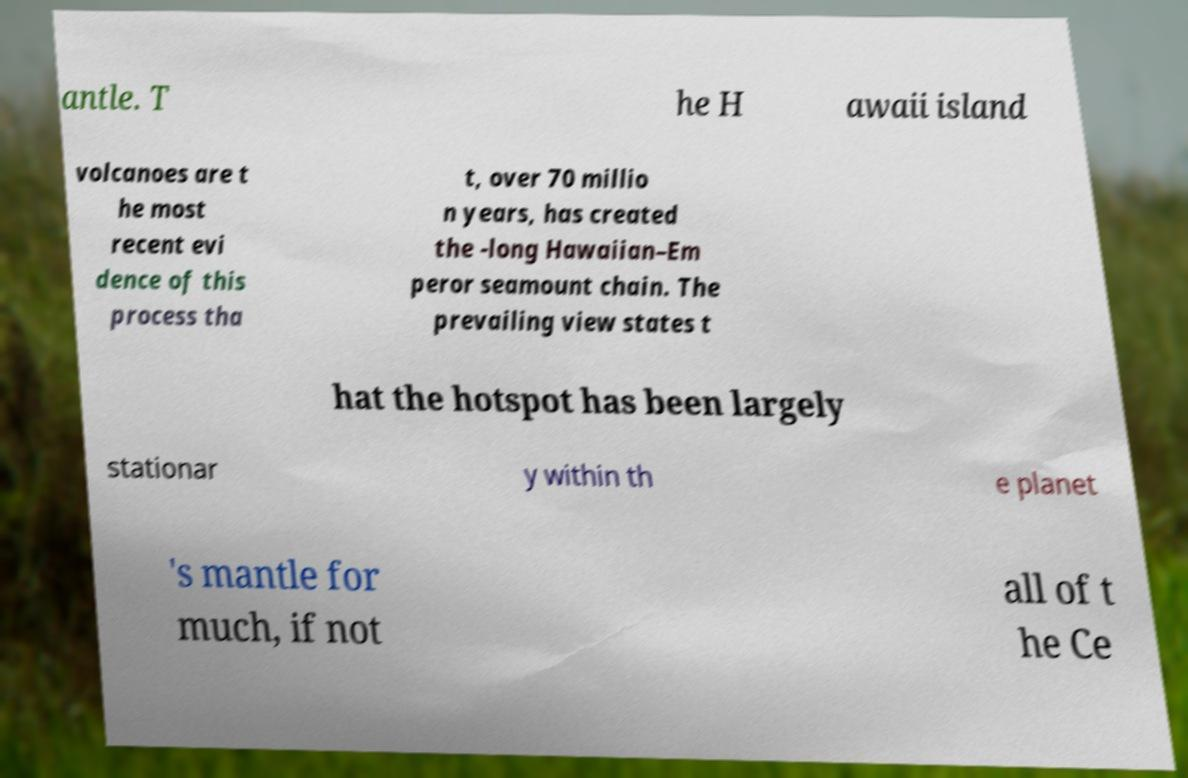Can you accurately transcribe the text from the provided image for me? antle. T he H awaii island volcanoes are t he most recent evi dence of this process tha t, over 70 millio n years, has created the -long Hawaiian–Em peror seamount chain. The prevailing view states t hat the hotspot has been largely stationar y within th e planet 's mantle for much, if not all of t he Ce 